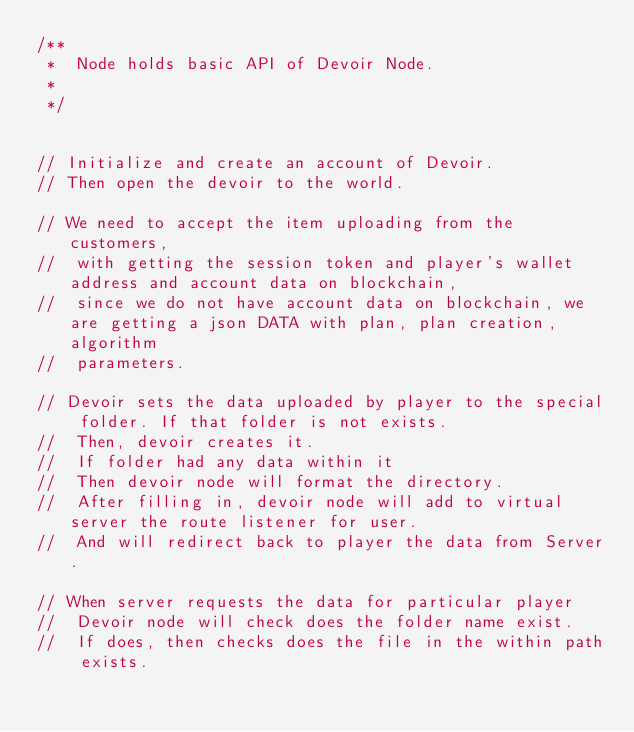Convert code to text. <code><loc_0><loc_0><loc_500><loc_500><_JavaScript_>/**
 *  Node holds basic API of Devoir Node.
 *
 */


// Initialize and create an account of Devoir.
// Then open the devoir to the world.

// We need to accept the item uploading from the customers,
//  with getting the session token and player's wallet address and account data on blockchain,
//  since we do not have account data on blockchain, we are getting a json DATA with plan, plan creation, algorithm
//  parameters.

// Devoir sets the data uploaded by player to the special folder. If that folder is not exists.
//  Then, devoir creates it.
//  If folder had any data within it
//  Then devoir node will format the directory.
//  After filling in, devoir node will add to virtual server the route listener for user.
//  And will redirect back to player the data from Server.

// When server requests the data for particular player
//  Devoir node will check does the folder name exist.
//  If does, then checks does the file in the within path exists.</code> 